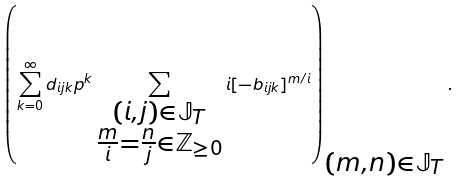Convert formula to latex. <formula><loc_0><loc_0><loc_500><loc_500>\left ( \sum _ { k = 0 } ^ { \infty } d _ { i j k } p ^ { k } \sum _ { \substack { ( i , j ) \in \mathbb { J } _ { T } \\ \frac { m } { i } = \frac { n } { j } \in \mathbb { Z } _ { \geq 0 } } } i [ - b _ { i j k } ] ^ { m / i } \right ) _ { \substack { ( m , n ) \in \mathbb { J } _ { T } } } .</formula> 